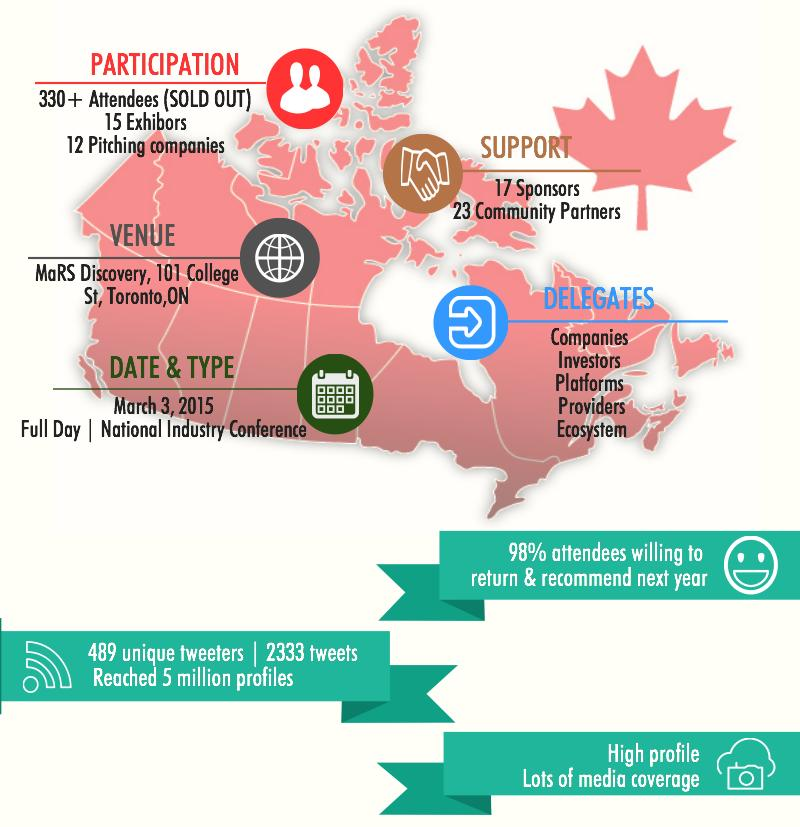List a handful of essential elements in this visual. A small percentage of conference attendees, approximately 2%, stated that they are not willing to return to the conference and recommend it for the next year. The National Industry Conference, held in Toronto, featured 15 exhibitors. The National Industry Conference was attended by 330 and more people in Toronto. The National Industry Conference held in Toronto lasted for an entire day. A total of 23 community partners were involved in organizing the National Industry Conference. 